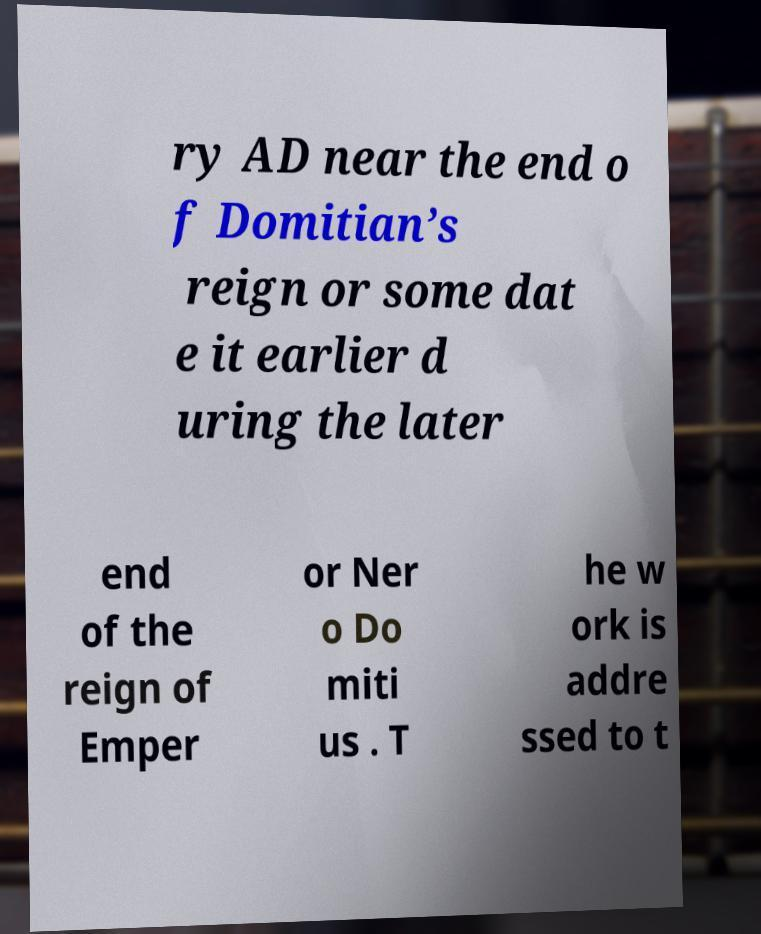Can you read and provide the text displayed in the image?This photo seems to have some interesting text. Can you extract and type it out for me? ry AD near the end o f Domitian’s reign or some dat e it earlier d uring the later end of the reign of Emper or Ner o Do miti us . T he w ork is addre ssed to t 